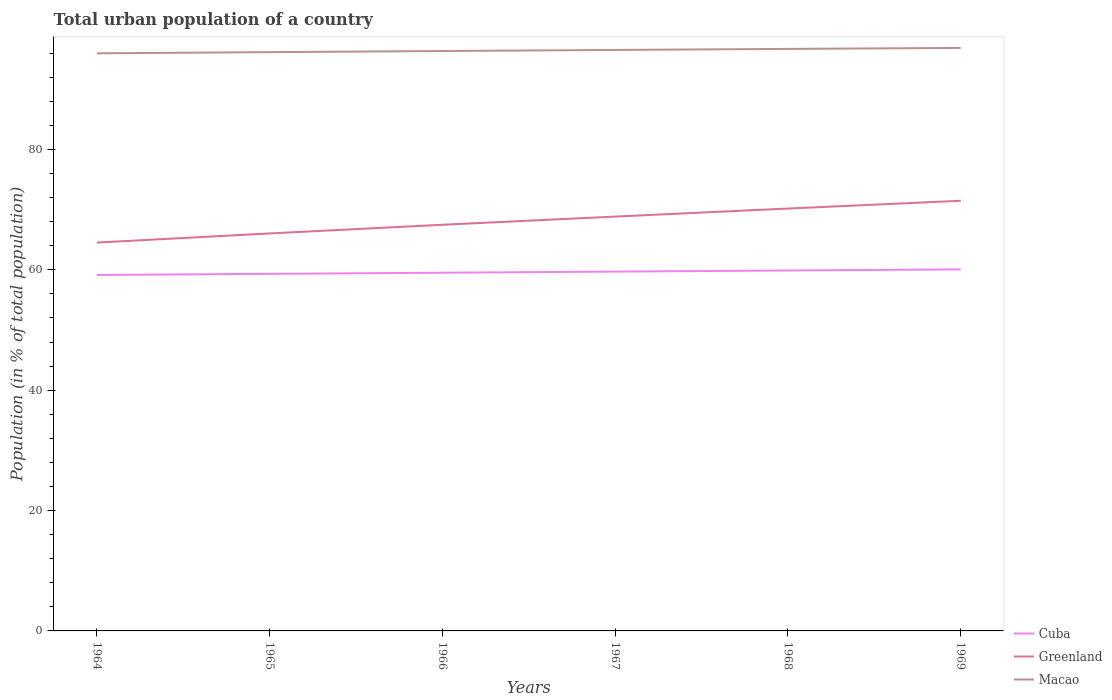Does the line corresponding to Greenland intersect with the line corresponding to Macao?
Keep it short and to the point. No. Across all years, what is the maximum urban population in Cuba?
Keep it short and to the point. 59.15. In which year was the urban population in Cuba maximum?
Provide a succinct answer. 1964. What is the total urban population in Cuba in the graph?
Your response must be concise. -0.74. What is the difference between the highest and the second highest urban population in Greenland?
Your answer should be compact. 6.95. How many years are there in the graph?
Provide a succinct answer. 6. Are the values on the major ticks of Y-axis written in scientific E-notation?
Ensure brevity in your answer.  No. Does the graph contain any zero values?
Ensure brevity in your answer.  No. Does the graph contain grids?
Your response must be concise. No. How are the legend labels stacked?
Make the answer very short. Vertical. What is the title of the graph?
Your answer should be compact. Total urban population of a country. Does "Monaco" appear as one of the legend labels in the graph?
Your answer should be very brief. No. What is the label or title of the Y-axis?
Ensure brevity in your answer.  Population (in % of total population). What is the Population (in % of total population) in Cuba in 1964?
Ensure brevity in your answer.  59.15. What is the Population (in % of total population) in Greenland in 1964?
Keep it short and to the point. 64.53. What is the Population (in % of total population) in Macao in 1964?
Ensure brevity in your answer.  95.98. What is the Population (in % of total population) in Cuba in 1965?
Your answer should be very brief. 59.34. What is the Population (in % of total population) in Greenland in 1965?
Keep it short and to the point. 66.05. What is the Population (in % of total population) in Macao in 1965?
Your response must be concise. 96.18. What is the Population (in % of total population) in Cuba in 1966?
Give a very brief answer. 59.52. What is the Population (in % of total population) in Greenland in 1966?
Your answer should be very brief. 67.49. What is the Population (in % of total population) in Macao in 1966?
Your answer should be very brief. 96.36. What is the Population (in % of total population) in Cuba in 1967?
Give a very brief answer. 59.71. What is the Population (in % of total population) in Greenland in 1967?
Keep it short and to the point. 68.85. What is the Population (in % of total population) in Macao in 1967?
Ensure brevity in your answer.  96.54. What is the Population (in % of total population) of Cuba in 1968?
Offer a very short reply. 59.9. What is the Population (in % of total population) of Greenland in 1968?
Make the answer very short. 70.19. What is the Population (in % of total population) in Macao in 1968?
Offer a terse response. 96.72. What is the Population (in % of total population) in Cuba in 1969?
Your answer should be very brief. 60.08. What is the Population (in % of total population) in Greenland in 1969?
Provide a short and direct response. 71.48. What is the Population (in % of total population) of Macao in 1969?
Make the answer very short. 96.88. Across all years, what is the maximum Population (in % of total population) of Cuba?
Ensure brevity in your answer.  60.08. Across all years, what is the maximum Population (in % of total population) in Greenland?
Provide a succinct answer. 71.48. Across all years, what is the maximum Population (in % of total population) in Macao?
Give a very brief answer. 96.88. Across all years, what is the minimum Population (in % of total population) in Cuba?
Your answer should be very brief. 59.15. Across all years, what is the minimum Population (in % of total population) of Greenland?
Give a very brief answer. 64.53. Across all years, what is the minimum Population (in % of total population) of Macao?
Give a very brief answer. 95.98. What is the total Population (in % of total population) in Cuba in the graph?
Provide a short and direct response. 357.69. What is the total Population (in % of total population) in Greenland in the graph?
Ensure brevity in your answer.  408.6. What is the total Population (in % of total population) in Macao in the graph?
Your answer should be compact. 578.66. What is the difference between the Population (in % of total population) of Cuba in 1964 and that in 1965?
Make the answer very short. -0.19. What is the difference between the Population (in % of total population) in Greenland in 1964 and that in 1965?
Your answer should be compact. -1.52. What is the difference between the Population (in % of total population) of Macao in 1964 and that in 1965?
Your answer should be compact. -0.2. What is the difference between the Population (in % of total population) of Cuba in 1964 and that in 1966?
Give a very brief answer. -0.37. What is the difference between the Population (in % of total population) in Greenland in 1964 and that in 1966?
Ensure brevity in your answer.  -2.96. What is the difference between the Population (in % of total population) in Macao in 1964 and that in 1966?
Provide a succinct answer. -0.39. What is the difference between the Population (in % of total population) of Cuba in 1964 and that in 1967?
Make the answer very short. -0.56. What is the difference between the Population (in % of total population) of Greenland in 1964 and that in 1967?
Offer a very short reply. -4.32. What is the difference between the Population (in % of total population) in Macao in 1964 and that in 1967?
Keep it short and to the point. -0.56. What is the difference between the Population (in % of total population) of Cuba in 1964 and that in 1968?
Keep it short and to the point. -0.74. What is the difference between the Population (in % of total population) in Greenland in 1964 and that in 1968?
Offer a terse response. -5.65. What is the difference between the Population (in % of total population) in Macao in 1964 and that in 1968?
Your answer should be very brief. -0.73. What is the difference between the Population (in % of total population) of Cuba in 1964 and that in 1969?
Offer a very short reply. -0.93. What is the difference between the Population (in % of total population) of Greenland in 1964 and that in 1969?
Your response must be concise. -6.95. What is the difference between the Population (in % of total population) in Macao in 1964 and that in 1969?
Offer a terse response. -0.9. What is the difference between the Population (in % of total population) in Cuba in 1965 and that in 1966?
Keep it short and to the point. -0.19. What is the difference between the Population (in % of total population) in Greenland in 1965 and that in 1966?
Your answer should be very brief. -1.44. What is the difference between the Population (in % of total population) in Macao in 1965 and that in 1966?
Provide a short and direct response. -0.19. What is the difference between the Population (in % of total population) in Cuba in 1965 and that in 1967?
Offer a terse response. -0.37. What is the difference between the Population (in % of total population) of Greenland in 1965 and that in 1967?
Offer a very short reply. -2.8. What is the difference between the Population (in % of total population) in Macao in 1965 and that in 1967?
Offer a terse response. -0.37. What is the difference between the Population (in % of total population) of Cuba in 1965 and that in 1968?
Provide a succinct answer. -0.56. What is the difference between the Population (in % of total population) of Greenland in 1965 and that in 1968?
Provide a short and direct response. -4.14. What is the difference between the Population (in % of total population) of Macao in 1965 and that in 1968?
Offer a terse response. -0.54. What is the difference between the Population (in % of total population) in Cuba in 1965 and that in 1969?
Ensure brevity in your answer.  -0.74. What is the difference between the Population (in % of total population) of Greenland in 1965 and that in 1969?
Make the answer very short. -5.43. What is the difference between the Population (in % of total population) in Cuba in 1966 and that in 1967?
Offer a terse response. -0.19. What is the difference between the Population (in % of total population) in Greenland in 1966 and that in 1967?
Your answer should be very brief. -1.36. What is the difference between the Population (in % of total population) in Macao in 1966 and that in 1967?
Offer a terse response. -0.18. What is the difference between the Population (in % of total population) of Cuba in 1966 and that in 1968?
Offer a very short reply. -0.37. What is the difference between the Population (in % of total population) in Greenland in 1966 and that in 1968?
Your response must be concise. -2.69. What is the difference between the Population (in % of total population) in Macao in 1966 and that in 1968?
Keep it short and to the point. -0.35. What is the difference between the Population (in % of total population) of Cuba in 1966 and that in 1969?
Your answer should be compact. -0.56. What is the difference between the Population (in % of total population) of Greenland in 1966 and that in 1969?
Your response must be concise. -3.99. What is the difference between the Population (in % of total population) of Macao in 1966 and that in 1969?
Offer a very short reply. -0.51. What is the difference between the Population (in % of total population) of Cuba in 1967 and that in 1968?
Provide a succinct answer. -0.19. What is the difference between the Population (in % of total population) of Greenland in 1967 and that in 1968?
Your response must be concise. -1.33. What is the difference between the Population (in % of total population) in Macao in 1967 and that in 1968?
Your answer should be compact. -0.17. What is the difference between the Population (in % of total population) of Cuba in 1967 and that in 1969?
Offer a very short reply. -0.37. What is the difference between the Population (in % of total population) of Greenland in 1967 and that in 1969?
Provide a short and direct response. -2.63. What is the difference between the Population (in % of total population) in Macao in 1967 and that in 1969?
Offer a terse response. -0.33. What is the difference between the Population (in % of total population) in Cuba in 1968 and that in 1969?
Make the answer very short. -0.19. What is the difference between the Population (in % of total population) of Greenland in 1968 and that in 1969?
Keep it short and to the point. -1.29. What is the difference between the Population (in % of total population) in Macao in 1968 and that in 1969?
Keep it short and to the point. -0.16. What is the difference between the Population (in % of total population) of Cuba in 1964 and the Population (in % of total population) of Macao in 1965?
Ensure brevity in your answer.  -37.03. What is the difference between the Population (in % of total population) in Greenland in 1964 and the Population (in % of total population) in Macao in 1965?
Keep it short and to the point. -31.64. What is the difference between the Population (in % of total population) in Cuba in 1964 and the Population (in % of total population) in Greenland in 1966?
Your answer should be very brief. -8.34. What is the difference between the Population (in % of total population) of Cuba in 1964 and the Population (in % of total population) of Macao in 1966?
Provide a short and direct response. -37.22. What is the difference between the Population (in % of total population) of Greenland in 1964 and the Population (in % of total population) of Macao in 1966?
Keep it short and to the point. -31.83. What is the difference between the Population (in % of total population) in Cuba in 1964 and the Population (in % of total population) in Greenland in 1967?
Offer a terse response. -9.7. What is the difference between the Population (in % of total population) in Cuba in 1964 and the Population (in % of total population) in Macao in 1967?
Your answer should be compact. -37.39. What is the difference between the Population (in % of total population) of Greenland in 1964 and the Population (in % of total population) of Macao in 1967?
Give a very brief answer. -32.01. What is the difference between the Population (in % of total population) in Cuba in 1964 and the Population (in % of total population) in Greenland in 1968?
Offer a very short reply. -11.04. What is the difference between the Population (in % of total population) in Cuba in 1964 and the Population (in % of total population) in Macao in 1968?
Provide a succinct answer. -37.56. What is the difference between the Population (in % of total population) in Greenland in 1964 and the Population (in % of total population) in Macao in 1968?
Ensure brevity in your answer.  -32.18. What is the difference between the Population (in % of total population) in Cuba in 1964 and the Population (in % of total population) in Greenland in 1969?
Your answer should be very brief. -12.33. What is the difference between the Population (in % of total population) of Cuba in 1964 and the Population (in % of total population) of Macao in 1969?
Provide a short and direct response. -37.73. What is the difference between the Population (in % of total population) of Greenland in 1964 and the Population (in % of total population) of Macao in 1969?
Provide a succinct answer. -32.34. What is the difference between the Population (in % of total population) in Cuba in 1965 and the Population (in % of total population) in Greenland in 1966?
Ensure brevity in your answer.  -8.15. What is the difference between the Population (in % of total population) of Cuba in 1965 and the Population (in % of total population) of Macao in 1966?
Your response must be concise. -37.03. What is the difference between the Population (in % of total population) of Greenland in 1965 and the Population (in % of total population) of Macao in 1966?
Your answer should be compact. -30.32. What is the difference between the Population (in % of total population) in Cuba in 1965 and the Population (in % of total population) in Greenland in 1967?
Offer a terse response. -9.52. What is the difference between the Population (in % of total population) in Cuba in 1965 and the Population (in % of total population) in Macao in 1967?
Offer a very short reply. -37.21. What is the difference between the Population (in % of total population) of Greenland in 1965 and the Population (in % of total population) of Macao in 1967?
Provide a short and direct response. -30.49. What is the difference between the Population (in % of total population) in Cuba in 1965 and the Population (in % of total population) in Greenland in 1968?
Offer a very short reply. -10.85. What is the difference between the Population (in % of total population) of Cuba in 1965 and the Population (in % of total population) of Macao in 1968?
Provide a short and direct response. -37.38. What is the difference between the Population (in % of total population) of Greenland in 1965 and the Population (in % of total population) of Macao in 1968?
Offer a terse response. -30.66. What is the difference between the Population (in % of total population) of Cuba in 1965 and the Population (in % of total population) of Greenland in 1969?
Provide a short and direct response. -12.14. What is the difference between the Population (in % of total population) of Cuba in 1965 and the Population (in % of total population) of Macao in 1969?
Provide a succinct answer. -37.54. What is the difference between the Population (in % of total population) in Greenland in 1965 and the Population (in % of total population) in Macao in 1969?
Offer a terse response. -30.83. What is the difference between the Population (in % of total population) in Cuba in 1966 and the Population (in % of total population) in Greenland in 1967?
Ensure brevity in your answer.  -9.33. What is the difference between the Population (in % of total population) in Cuba in 1966 and the Population (in % of total population) in Macao in 1967?
Provide a short and direct response. -37.02. What is the difference between the Population (in % of total population) of Greenland in 1966 and the Population (in % of total population) of Macao in 1967?
Provide a short and direct response. -29.05. What is the difference between the Population (in % of total population) of Cuba in 1966 and the Population (in % of total population) of Greenland in 1968?
Ensure brevity in your answer.  -10.66. What is the difference between the Population (in % of total population) in Cuba in 1966 and the Population (in % of total population) in Macao in 1968?
Your answer should be very brief. -37.19. What is the difference between the Population (in % of total population) of Greenland in 1966 and the Population (in % of total population) of Macao in 1968?
Offer a terse response. -29.22. What is the difference between the Population (in % of total population) in Cuba in 1966 and the Population (in % of total population) in Greenland in 1969?
Make the answer very short. -11.96. What is the difference between the Population (in % of total population) in Cuba in 1966 and the Population (in % of total population) in Macao in 1969?
Offer a terse response. -37.35. What is the difference between the Population (in % of total population) in Greenland in 1966 and the Population (in % of total population) in Macao in 1969?
Keep it short and to the point. -29.39. What is the difference between the Population (in % of total population) of Cuba in 1967 and the Population (in % of total population) of Greenland in 1968?
Ensure brevity in your answer.  -10.48. What is the difference between the Population (in % of total population) of Cuba in 1967 and the Population (in % of total population) of Macao in 1968?
Keep it short and to the point. -37.01. What is the difference between the Population (in % of total population) of Greenland in 1967 and the Population (in % of total population) of Macao in 1968?
Keep it short and to the point. -27.86. What is the difference between the Population (in % of total population) of Cuba in 1967 and the Population (in % of total population) of Greenland in 1969?
Offer a very short reply. -11.77. What is the difference between the Population (in % of total population) of Cuba in 1967 and the Population (in % of total population) of Macao in 1969?
Give a very brief answer. -37.17. What is the difference between the Population (in % of total population) in Greenland in 1967 and the Population (in % of total population) in Macao in 1969?
Your response must be concise. -28.02. What is the difference between the Population (in % of total population) in Cuba in 1968 and the Population (in % of total population) in Greenland in 1969?
Your answer should be very brief. -11.59. What is the difference between the Population (in % of total population) in Cuba in 1968 and the Population (in % of total population) in Macao in 1969?
Make the answer very short. -36.98. What is the difference between the Population (in % of total population) of Greenland in 1968 and the Population (in % of total population) of Macao in 1969?
Give a very brief answer. -26.69. What is the average Population (in % of total population) in Cuba per year?
Provide a short and direct response. 59.62. What is the average Population (in % of total population) in Greenland per year?
Your answer should be very brief. 68.1. What is the average Population (in % of total population) of Macao per year?
Make the answer very short. 96.44. In the year 1964, what is the difference between the Population (in % of total population) in Cuba and Population (in % of total population) in Greenland?
Offer a very short reply. -5.38. In the year 1964, what is the difference between the Population (in % of total population) of Cuba and Population (in % of total population) of Macao?
Offer a very short reply. -36.83. In the year 1964, what is the difference between the Population (in % of total population) in Greenland and Population (in % of total population) in Macao?
Your response must be concise. -31.45. In the year 1965, what is the difference between the Population (in % of total population) in Cuba and Population (in % of total population) in Greenland?
Your response must be concise. -6.71. In the year 1965, what is the difference between the Population (in % of total population) of Cuba and Population (in % of total population) of Macao?
Make the answer very short. -36.84. In the year 1965, what is the difference between the Population (in % of total population) of Greenland and Population (in % of total population) of Macao?
Offer a very short reply. -30.13. In the year 1966, what is the difference between the Population (in % of total population) in Cuba and Population (in % of total population) in Greenland?
Your answer should be compact. -7.97. In the year 1966, what is the difference between the Population (in % of total population) of Cuba and Population (in % of total population) of Macao?
Make the answer very short. -36.84. In the year 1966, what is the difference between the Population (in % of total population) in Greenland and Population (in % of total population) in Macao?
Your response must be concise. -28.87. In the year 1967, what is the difference between the Population (in % of total population) of Cuba and Population (in % of total population) of Greenland?
Your answer should be very brief. -9.14. In the year 1967, what is the difference between the Population (in % of total population) in Cuba and Population (in % of total population) in Macao?
Your answer should be very brief. -36.84. In the year 1967, what is the difference between the Population (in % of total population) of Greenland and Population (in % of total population) of Macao?
Keep it short and to the point. -27.69. In the year 1968, what is the difference between the Population (in % of total population) of Cuba and Population (in % of total population) of Greenland?
Your answer should be very brief. -10.29. In the year 1968, what is the difference between the Population (in % of total population) of Cuba and Population (in % of total population) of Macao?
Give a very brief answer. -36.82. In the year 1968, what is the difference between the Population (in % of total population) in Greenland and Population (in % of total population) in Macao?
Offer a terse response. -26.53. In the year 1969, what is the difference between the Population (in % of total population) of Cuba and Population (in % of total population) of Greenland?
Offer a terse response. -11.4. In the year 1969, what is the difference between the Population (in % of total population) in Cuba and Population (in % of total population) in Macao?
Offer a very short reply. -36.8. In the year 1969, what is the difference between the Population (in % of total population) in Greenland and Population (in % of total population) in Macao?
Offer a very short reply. -25.4. What is the ratio of the Population (in % of total population) of Greenland in 1964 to that in 1965?
Provide a succinct answer. 0.98. What is the ratio of the Population (in % of total population) of Greenland in 1964 to that in 1966?
Your answer should be very brief. 0.96. What is the ratio of the Population (in % of total population) in Macao in 1964 to that in 1966?
Your response must be concise. 1. What is the ratio of the Population (in % of total population) of Cuba in 1964 to that in 1967?
Your answer should be compact. 0.99. What is the ratio of the Population (in % of total population) in Greenland in 1964 to that in 1967?
Keep it short and to the point. 0.94. What is the ratio of the Population (in % of total population) of Macao in 1964 to that in 1967?
Make the answer very short. 0.99. What is the ratio of the Population (in % of total population) in Cuba in 1964 to that in 1968?
Offer a terse response. 0.99. What is the ratio of the Population (in % of total population) of Greenland in 1964 to that in 1968?
Your answer should be compact. 0.92. What is the ratio of the Population (in % of total population) in Cuba in 1964 to that in 1969?
Provide a short and direct response. 0.98. What is the ratio of the Population (in % of total population) of Greenland in 1964 to that in 1969?
Give a very brief answer. 0.9. What is the ratio of the Population (in % of total population) of Greenland in 1965 to that in 1966?
Provide a short and direct response. 0.98. What is the ratio of the Population (in % of total population) in Macao in 1965 to that in 1966?
Offer a terse response. 1. What is the ratio of the Population (in % of total population) in Greenland in 1965 to that in 1967?
Your answer should be very brief. 0.96. What is the ratio of the Population (in % of total population) in Greenland in 1965 to that in 1968?
Provide a succinct answer. 0.94. What is the ratio of the Population (in % of total population) in Cuba in 1965 to that in 1969?
Offer a very short reply. 0.99. What is the ratio of the Population (in % of total population) of Greenland in 1965 to that in 1969?
Provide a short and direct response. 0.92. What is the ratio of the Population (in % of total population) of Macao in 1965 to that in 1969?
Provide a short and direct response. 0.99. What is the ratio of the Population (in % of total population) in Cuba in 1966 to that in 1967?
Offer a terse response. 1. What is the ratio of the Population (in % of total population) of Greenland in 1966 to that in 1967?
Your answer should be compact. 0.98. What is the ratio of the Population (in % of total population) in Cuba in 1966 to that in 1968?
Offer a terse response. 0.99. What is the ratio of the Population (in % of total population) of Greenland in 1966 to that in 1968?
Give a very brief answer. 0.96. What is the ratio of the Population (in % of total population) in Cuba in 1966 to that in 1969?
Offer a terse response. 0.99. What is the ratio of the Population (in % of total population) in Greenland in 1966 to that in 1969?
Make the answer very short. 0.94. What is the ratio of the Population (in % of total population) of Greenland in 1967 to that in 1968?
Make the answer very short. 0.98. What is the ratio of the Population (in % of total population) in Greenland in 1967 to that in 1969?
Your response must be concise. 0.96. What is the ratio of the Population (in % of total population) in Cuba in 1968 to that in 1969?
Your response must be concise. 1. What is the ratio of the Population (in % of total population) of Greenland in 1968 to that in 1969?
Make the answer very short. 0.98. What is the ratio of the Population (in % of total population) in Macao in 1968 to that in 1969?
Keep it short and to the point. 1. What is the difference between the highest and the second highest Population (in % of total population) of Cuba?
Provide a short and direct response. 0.19. What is the difference between the highest and the second highest Population (in % of total population) of Greenland?
Offer a terse response. 1.29. What is the difference between the highest and the second highest Population (in % of total population) of Macao?
Your answer should be compact. 0.16. What is the difference between the highest and the lowest Population (in % of total population) of Greenland?
Keep it short and to the point. 6.95. What is the difference between the highest and the lowest Population (in % of total population) of Macao?
Keep it short and to the point. 0.9. 